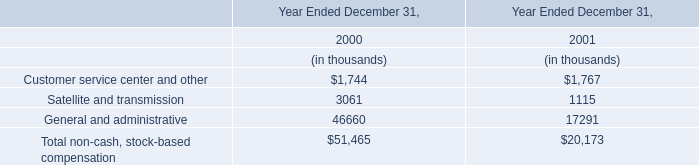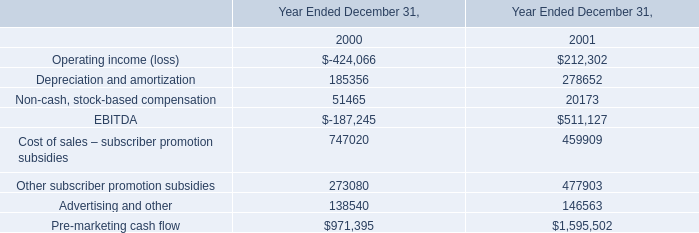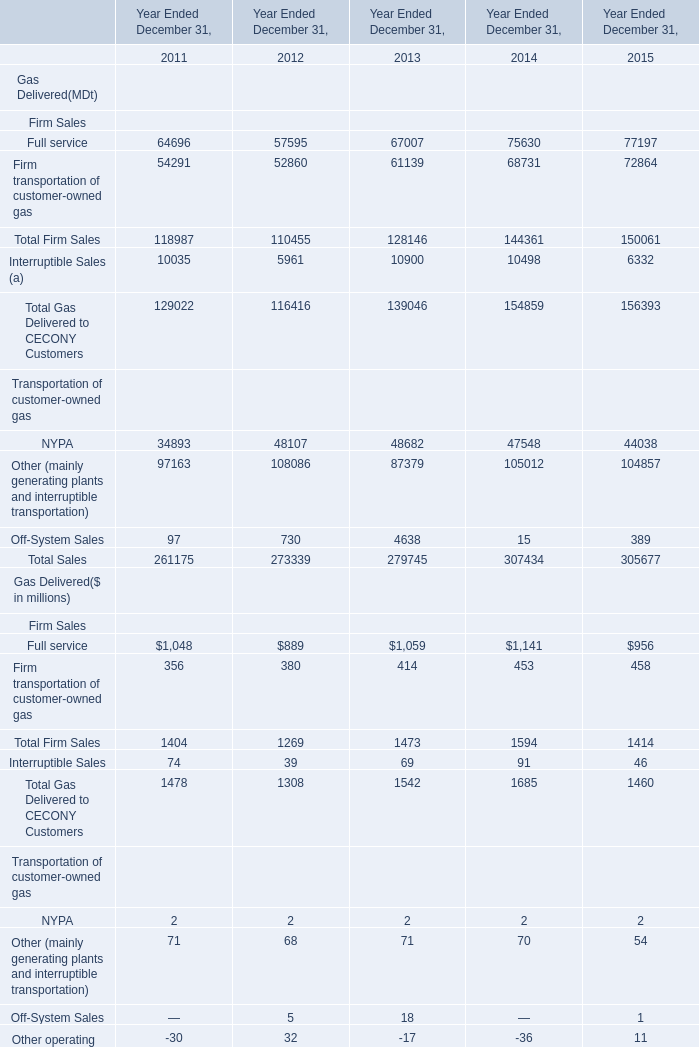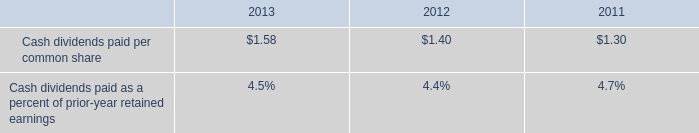Does the proportion of full service of Gas Delivered in total larger than that of Firm transportation of customer-owned gas in 2011? 
Answer: yes. 